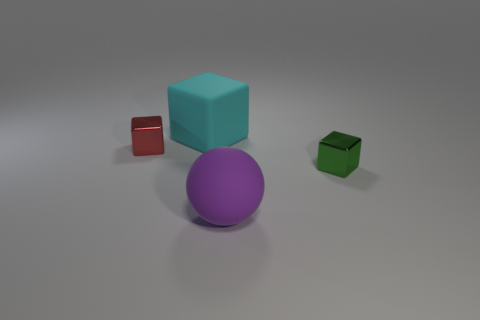Add 2 large green objects. How many objects exist? 6 Subtract all balls. How many objects are left? 3 Subtract 0 brown cylinders. How many objects are left? 4 Subtract all tiny blue blocks. Subtract all tiny objects. How many objects are left? 2 Add 2 large purple spheres. How many large purple spheres are left? 3 Add 4 small red shiny cubes. How many small red shiny cubes exist? 5 